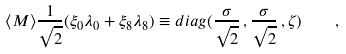Convert formula to latex. <formula><loc_0><loc_0><loc_500><loc_500>\langle M \rangle \frac { 1 } { \sqrt { 2 } } ( \xi _ { 0 } \lambda _ { 0 } + \xi _ { 8 } \lambda _ { 8 } ) \equiv d i a g ( \frac { \sigma } { \sqrt { 2 } } \, , \frac { \sigma } { \sqrt { 2 } } \, , \zeta ) \quad ,</formula> 